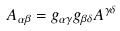<formula> <loc_0><loc_0><loc_500><loc_500>A _ { \alpha \beta } = g _ { \alpha \gamma } g _ { \beta \delta } A ^ { \gamma \delta }</formula> 